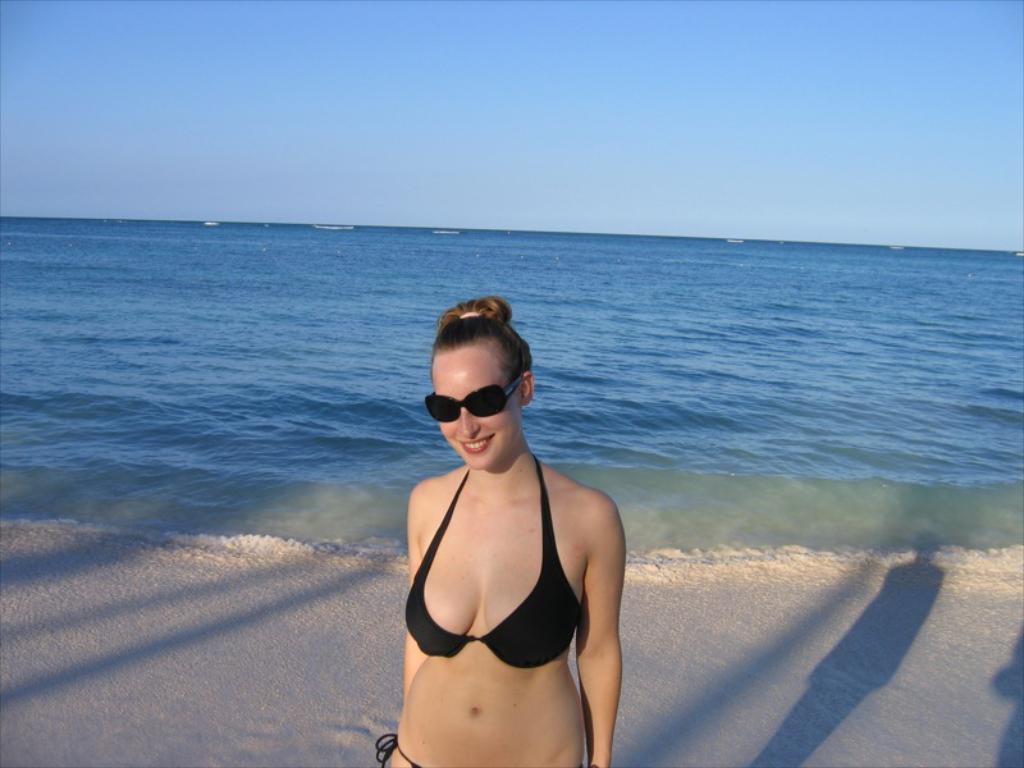How would you summarize this image in a sentence or two? In the center of the image a lady is standing and smiling and wearing goggles. In the background of the image we can see the water. At the bottom of the image we can see the soil. At the top of the image we can see the sky. In the middle of the image we can see the boats. 